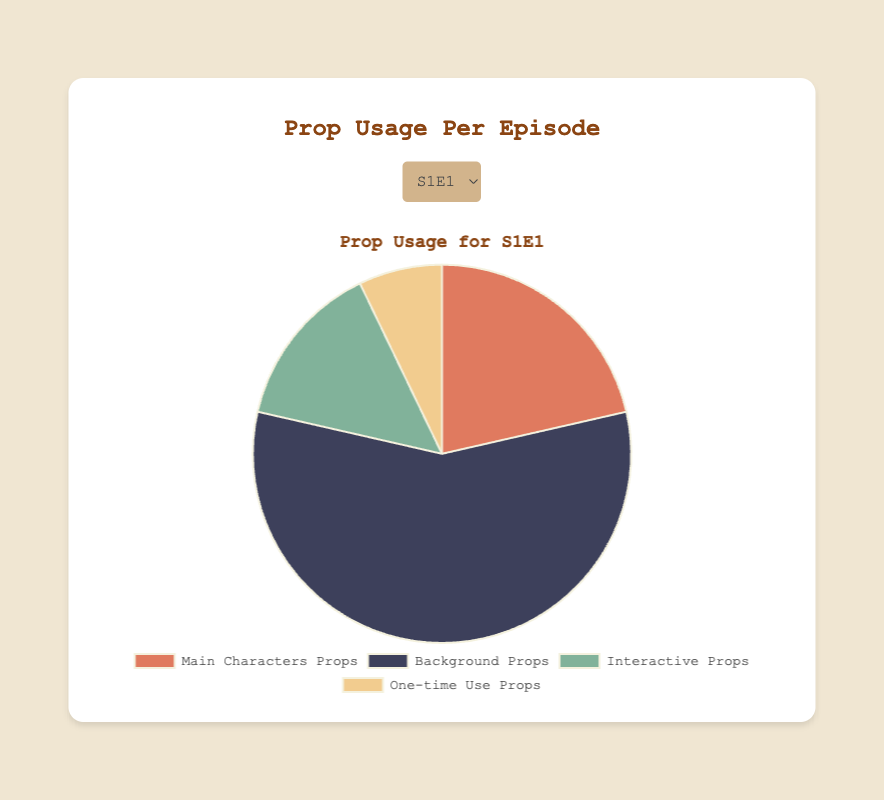Which type of prop is used the most in S1E3? The prop usage data for S1E3 shows that Background Props have the highest value at 42, compared to Main Characters' Props (18), Interactive Props (7), and One-time Use Props (3).
Answer: Background Props How many more Background Props than One-time Use Props are used in S1E2? Background Props in S1E2 are 35, while One-time Use Props are 9. The difference is 35 - 9 = 26.
Answer: 26 What is the average number of Interactive Props used per episode? Sum the Interactive Props across all episodes: 10 (S1E1) + 14 (S1E2) + 7 (S1E3) + 9 (S1E4) = 40. Then, divide by the number of episodes (4): 40 / 4 = 10.
Answer: 10 Which episode features the least amount of One-time Use Props? Observing the One-time Use Props across episodes, S1E3 has the least amount with 3 props compared to 5 in S1E1, 9 in S1E2, and 8 in S1E4.
Answer: S1E3 Are there more Main Characters' Props or Interactive Props in S1E4? In S1E4, there are 20 Main Characters' Props and 9 Interactive Props. Since 20 > 9, there are more Main Characters' Props.
Answer: Main Characters' Props How much do all One-time Use Props sum to across all episodes? Sum the One-time Use Props: 5 (S1E1) + 9 (S1E2) + 3 (S1E3) + 8 (S1E4) = 25.
Answer: 25 Which type of prop is represented by the third section in the pie chart for S1E1? Referring to the data sequence and color coding, the third section represents Interactive Props, with a quantity of 10.
Answer: Interactive Props What percentage of props used in S1E1 are Main Characters' Props? The total prop usage in S1E1 is 15 (Main Characters' Props) + 40 (Background Props) + 10 (Interactive Props) + 5 (One-time Use Props) = 70. The percentage is (15 / 70) * 100 ≈ 21.43%.
Answer: ≈ 21.43% Is the quantity of One-time Use Props the same in any two episodes? By comparing One-time Use Props across episodes: S1E1 (5), S1E2 (9), S1E3 (3), and S1E4 (8), no episodes have the same quantity.
Answer: No Which episode has the highest total number of props used? Calculate the total props used per episode: 
S1E1: 15 + 40 + 10 + 5 = 70, 
S1E2: 12 + 35 + 14 + 9 = 70,
S1E3: 18 + 42 + 7 + 3 = 70, 
S1E4: 20 + 30 + 9 + 8 = 67.
S1E1, S1E2, and S1E3 each have 70 props, but S1E4 has 67, so any of the first three have the highest total.
Answer: S1E1, S1E2, S1E3 